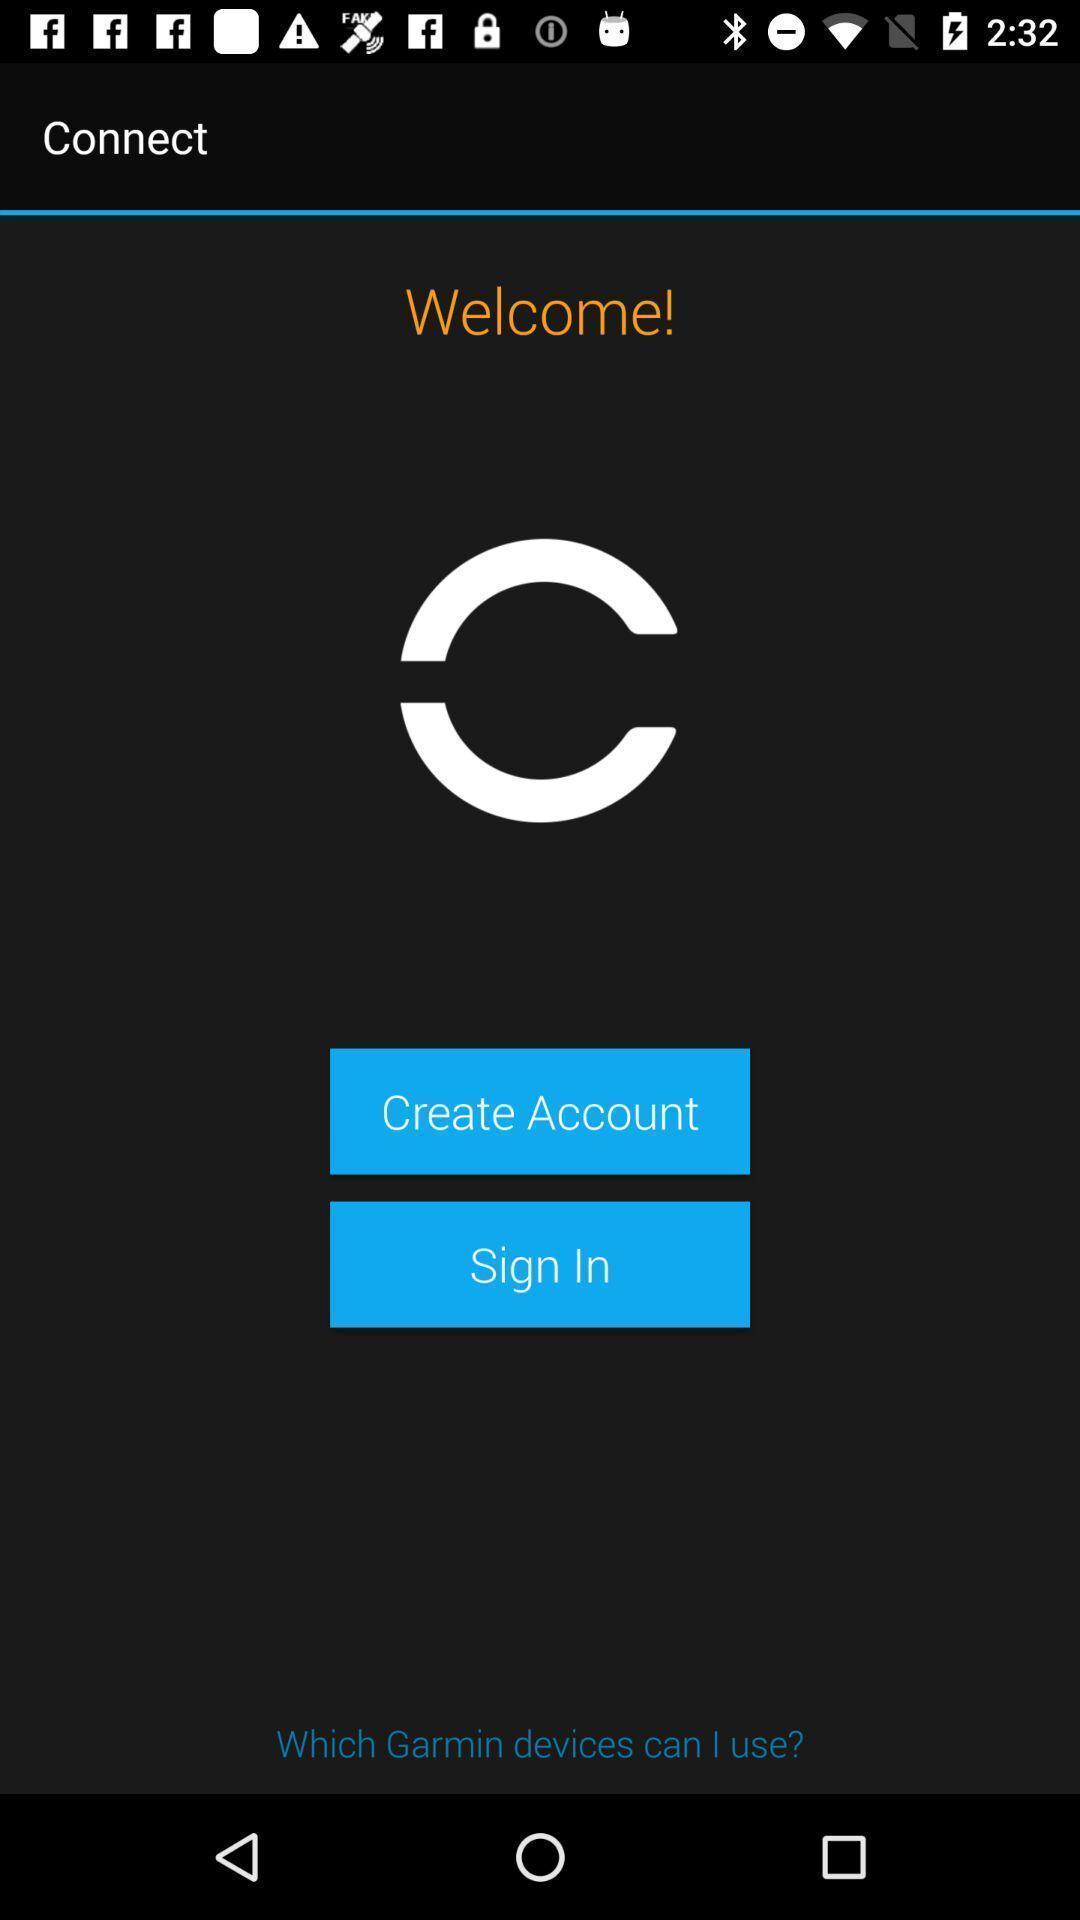What can you discern from this picture? Welcome page to sign in with app. 